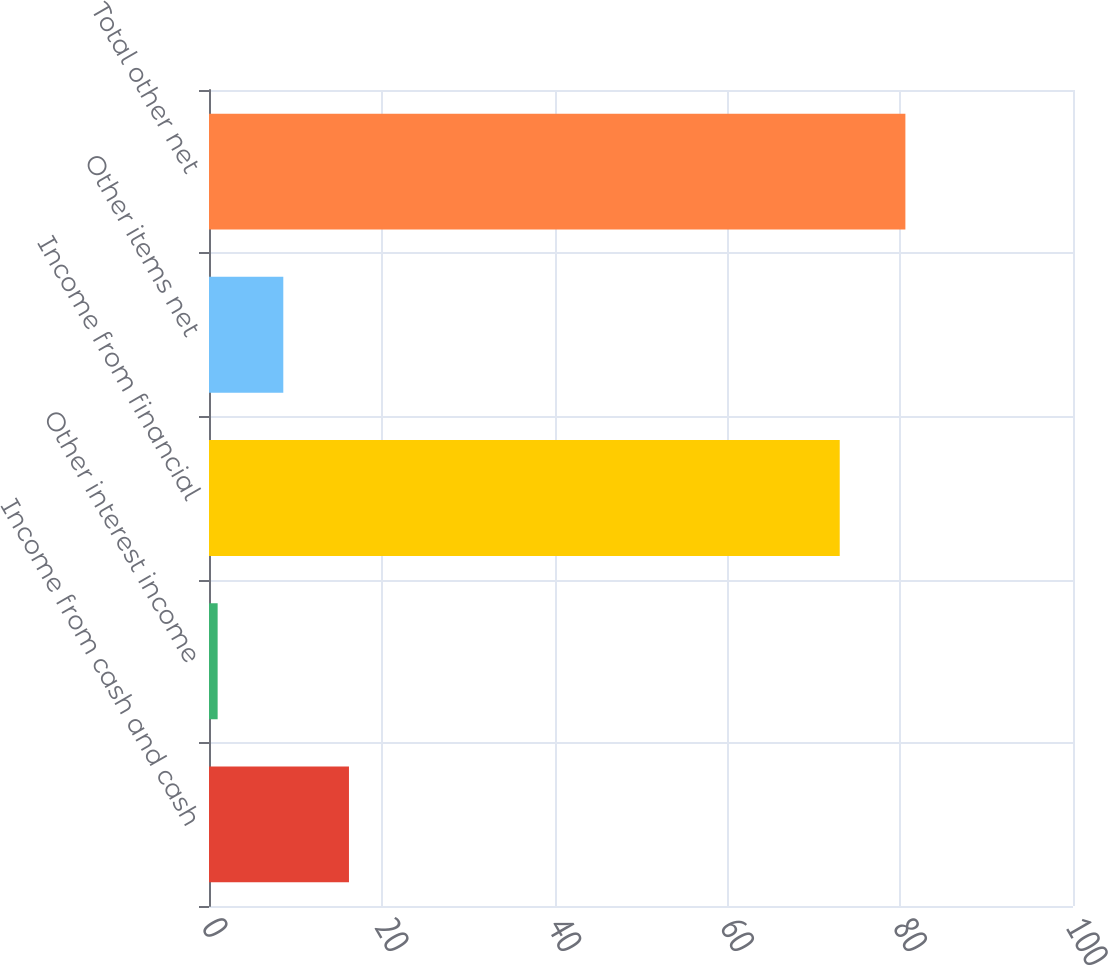Convert chart to OTSL. <chart><loc_0><loc_0><loc_500><loc_500><bar_chart><fcel>Income from cash and cash<fcel>Other interest income<fcel>Income from financial<fcel>Other items net<fcel>Total other net<nl><fcel>16.2<fcel>1<fcel>73<fcel>8.6<fcel>80.6<nl></chart> 